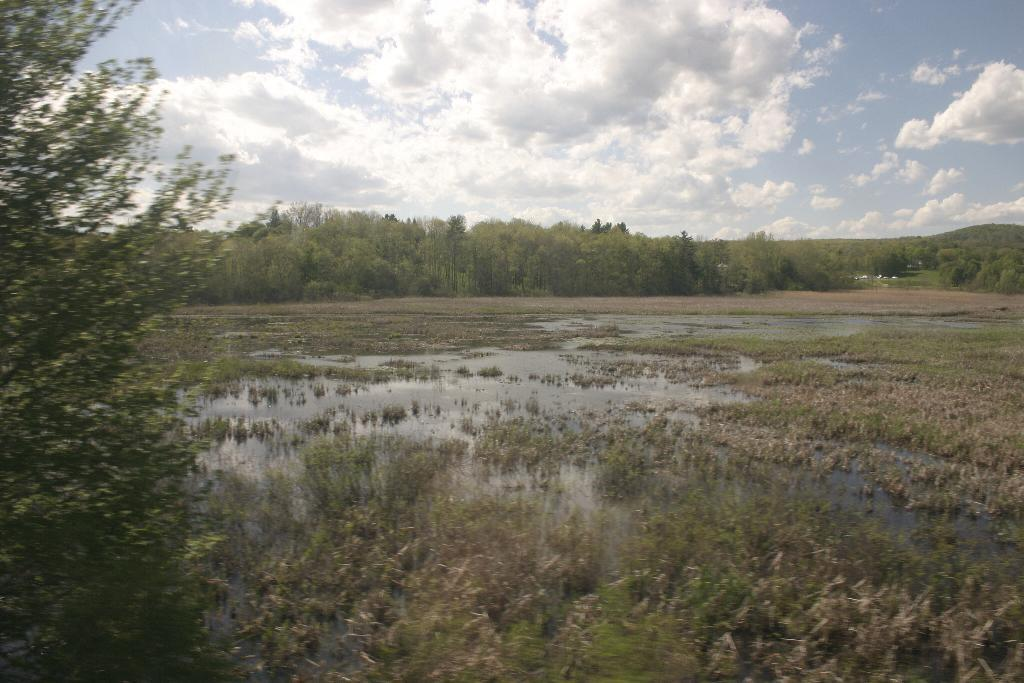What is one of the natural elements present in the image? There is water in the image. What type of vegetation can be seen in the image? There is grass and trees in the image. What is visible in the background of the image? The sky is visible in the background of the image. What can be observed in the sky? Clouds are present in the sky. How does the comb help the donkey in the image? There is no donkey or comb present in the image. 